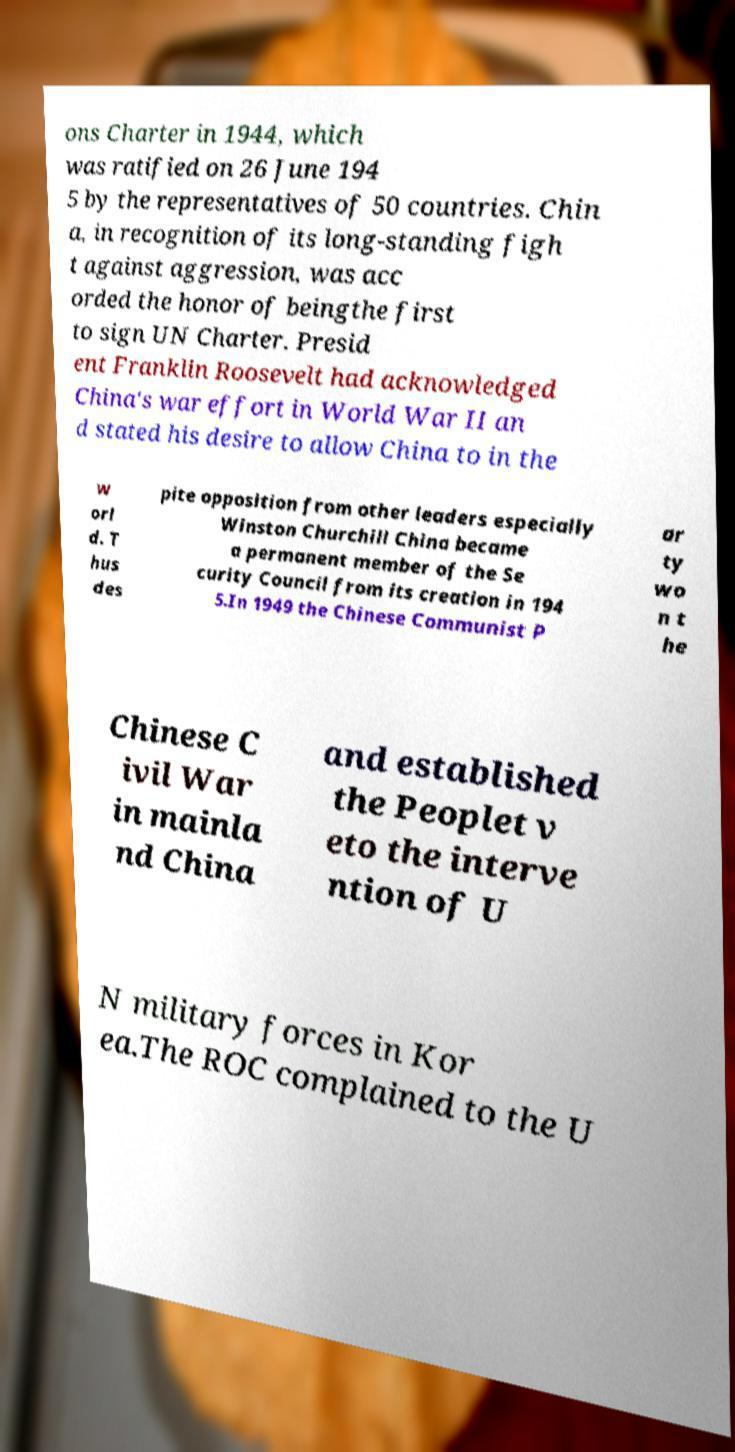Can you accurately transcribe the text from the provided image for me? ons Charter in 1944, which was ratified on 26 June 194 5 by the representatives of 50 countries. Chin a, in recognition of its long-standing figh t against aggression, was acc orded the honor of beingthe first to sign UN Charter. Presid ent Franklin Roosevelt had acknowledged China's war effort in World War II an d stated his desire to allow China to in the w orl d. T hus des pite opposition from other leaders especially Winston Churchill China became a permanent member of the Se curity Council from its creation in 194 5.In 1949 the Chinese Communist P ar ty wo n t he Chinese C ivil War in mainla nd China and established the Peoplet v eto the interve ntion of U N military forces in Kor ea.The ROC complained to the U 